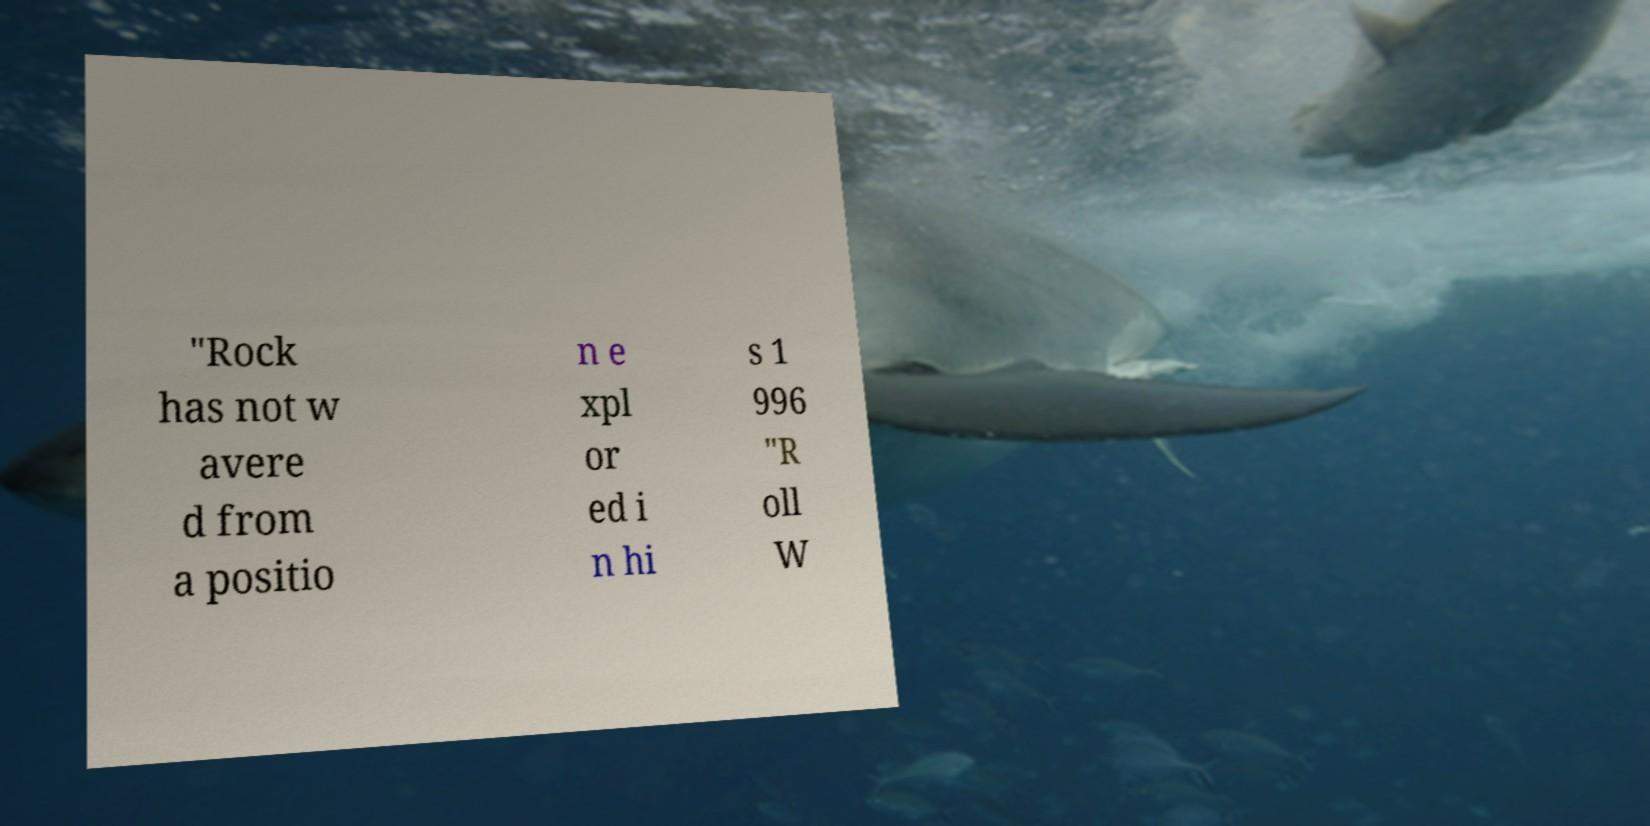There's text embedded in this image that I need extracted. Can you transcribe it verbatim? "Rock has not w avere d from a positio n e xpl or ed i n hi s 1 996 "R oll W 